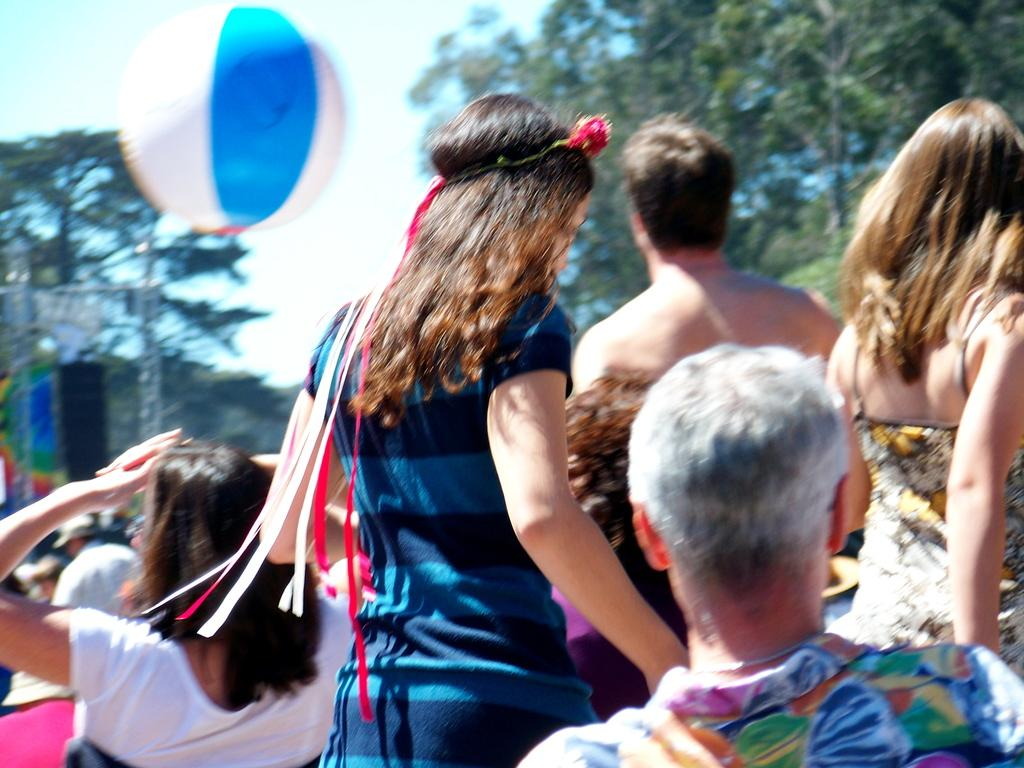How many people are in the group visible in the image? There is a group of people in the image, but the exact number cannot be determined from the provided facts. What is the object floating in the image? There is a balloon in the image. What type of vegetation can be seen in the image? There are trees in the image. Can you describe any objects in the image? Yes, there are some objects in the image, but their specific nature cannot be determined from the provided facts. What is visible in the background of the image? The sky is visible in the background of the image. What is the grandmother reading to the group of people in the image? There is no mention of a grandmother or any reading activity in the image. 